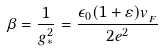<formula> <loc_0><loc_0><loc_500><loc_500>\beta = \frac { 1 } { g _ { * } ^ { 2 } } = \frac { \epsilon _ { 0 } ( 1 + \varepsilon ) v _ { _ { F } } } { 2 e ^ { 2 } }</formula> 